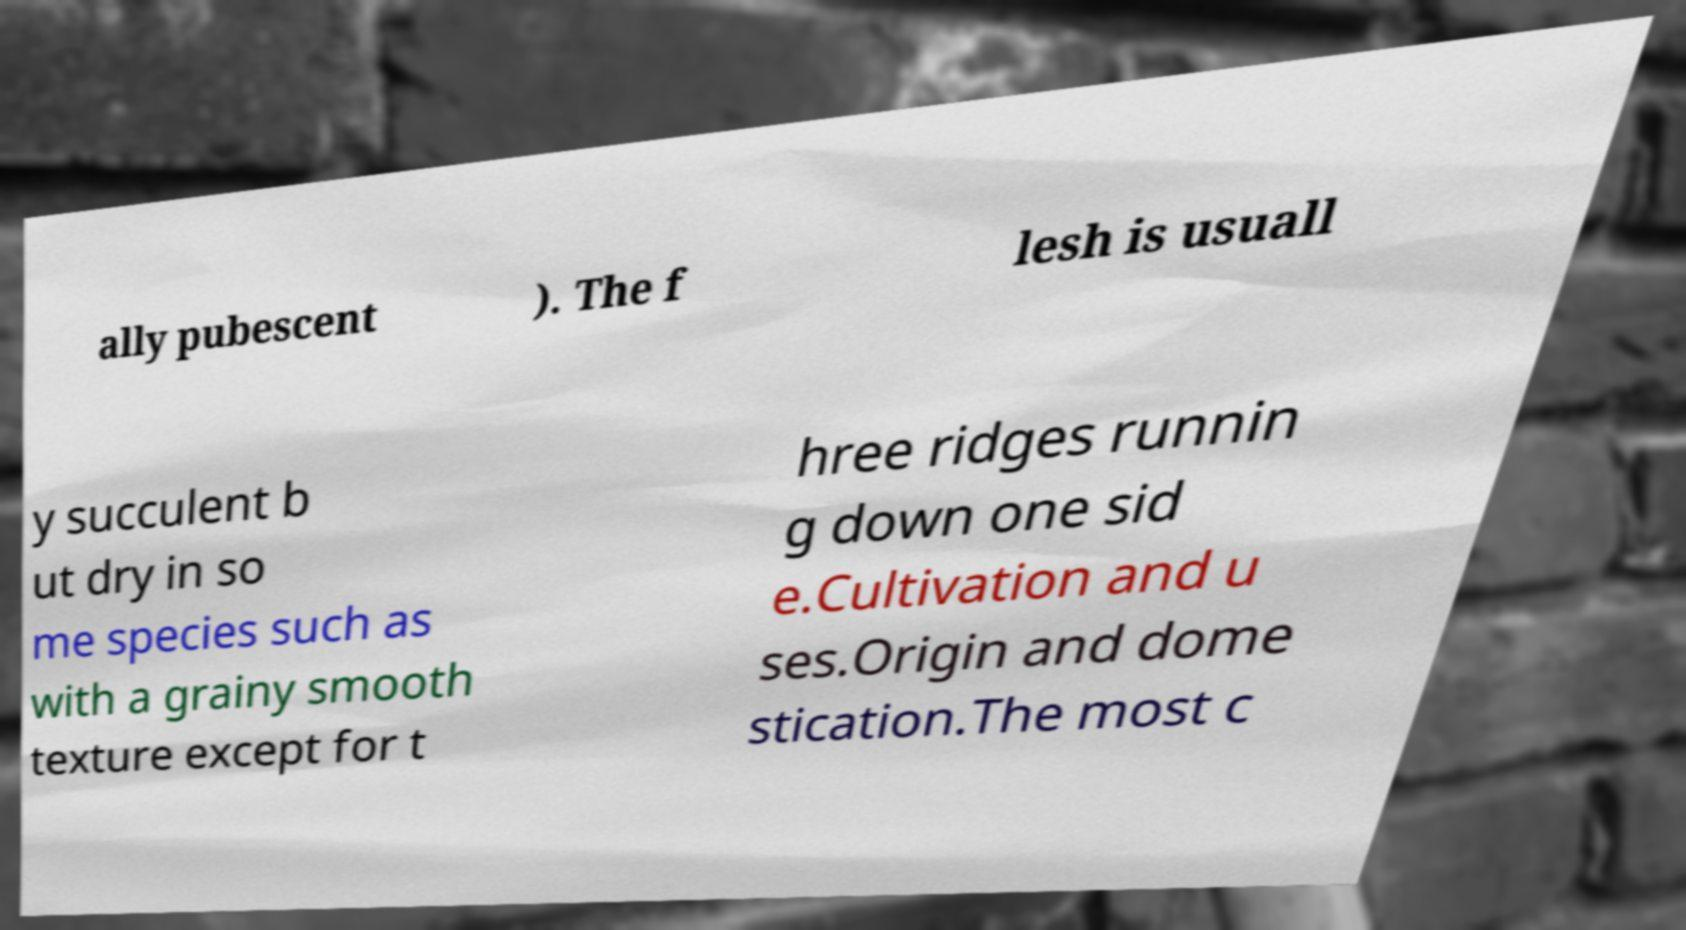I need the written content from this picture converted into text. Can you do that? ally pubescent ). The f lesh is usuall y succulent b ut dry in so me species such as with a grainy smooth texture except for t hree ridges runnin g down one sid e.Cultivation and u ses.Origin and dome stication.The most c 